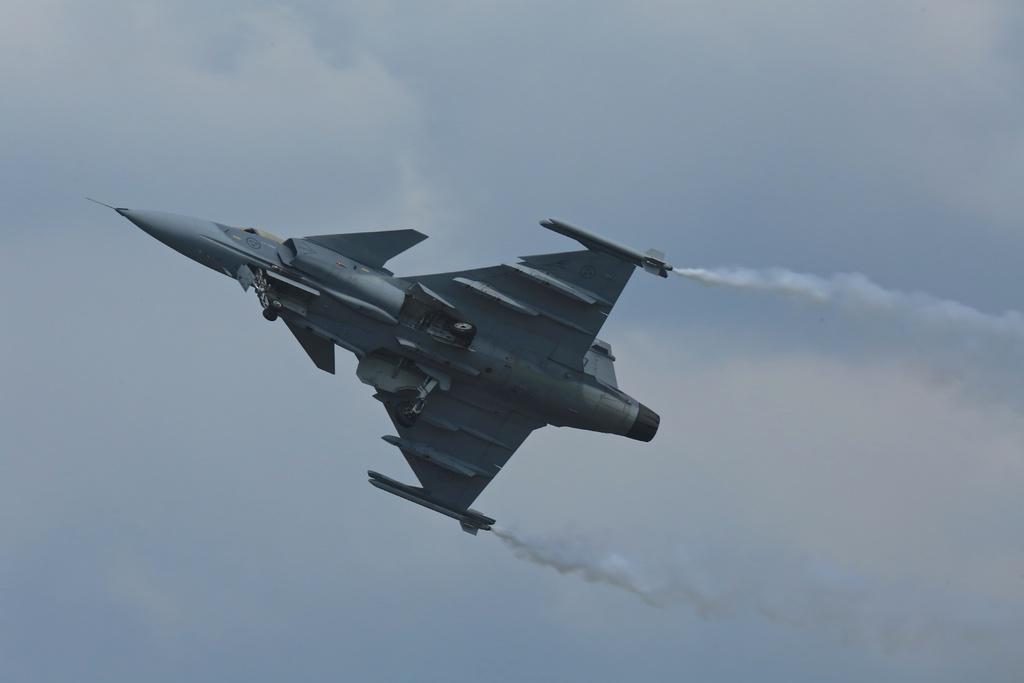Can you describe this image briefly? In this image there is a fighter jet plane in the sky. 